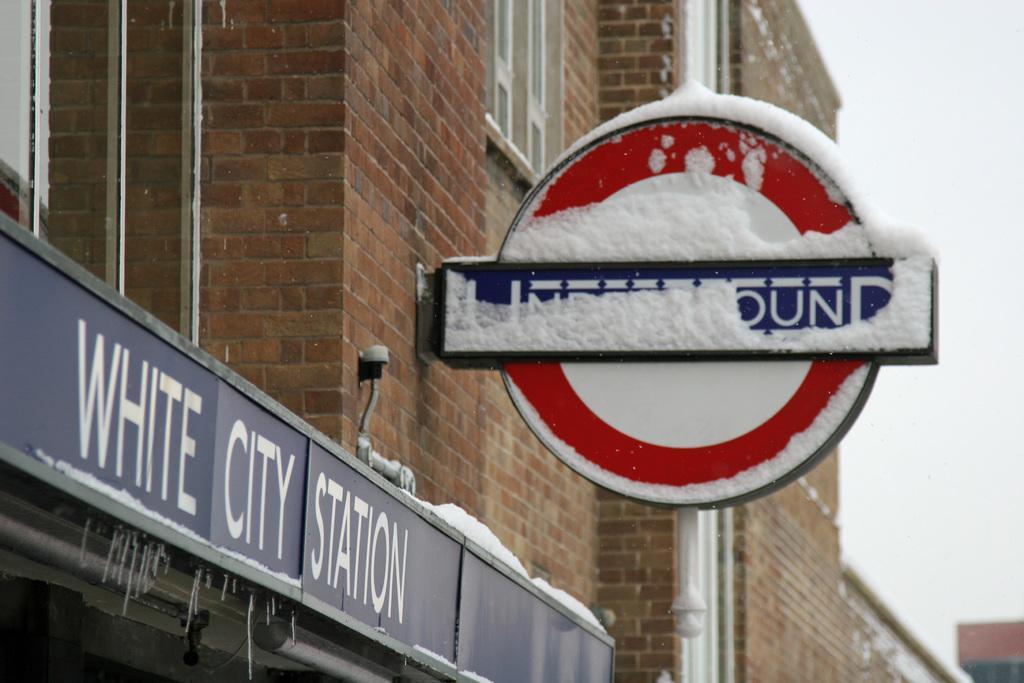Could you give a brief overview of what you see in this image? In the image there is a pole with sign board which is covered with snow. On the left side of the image there is a name board with name. And also there is a brick wall with glass windows and pipes. On the right side of the image there is sky. 